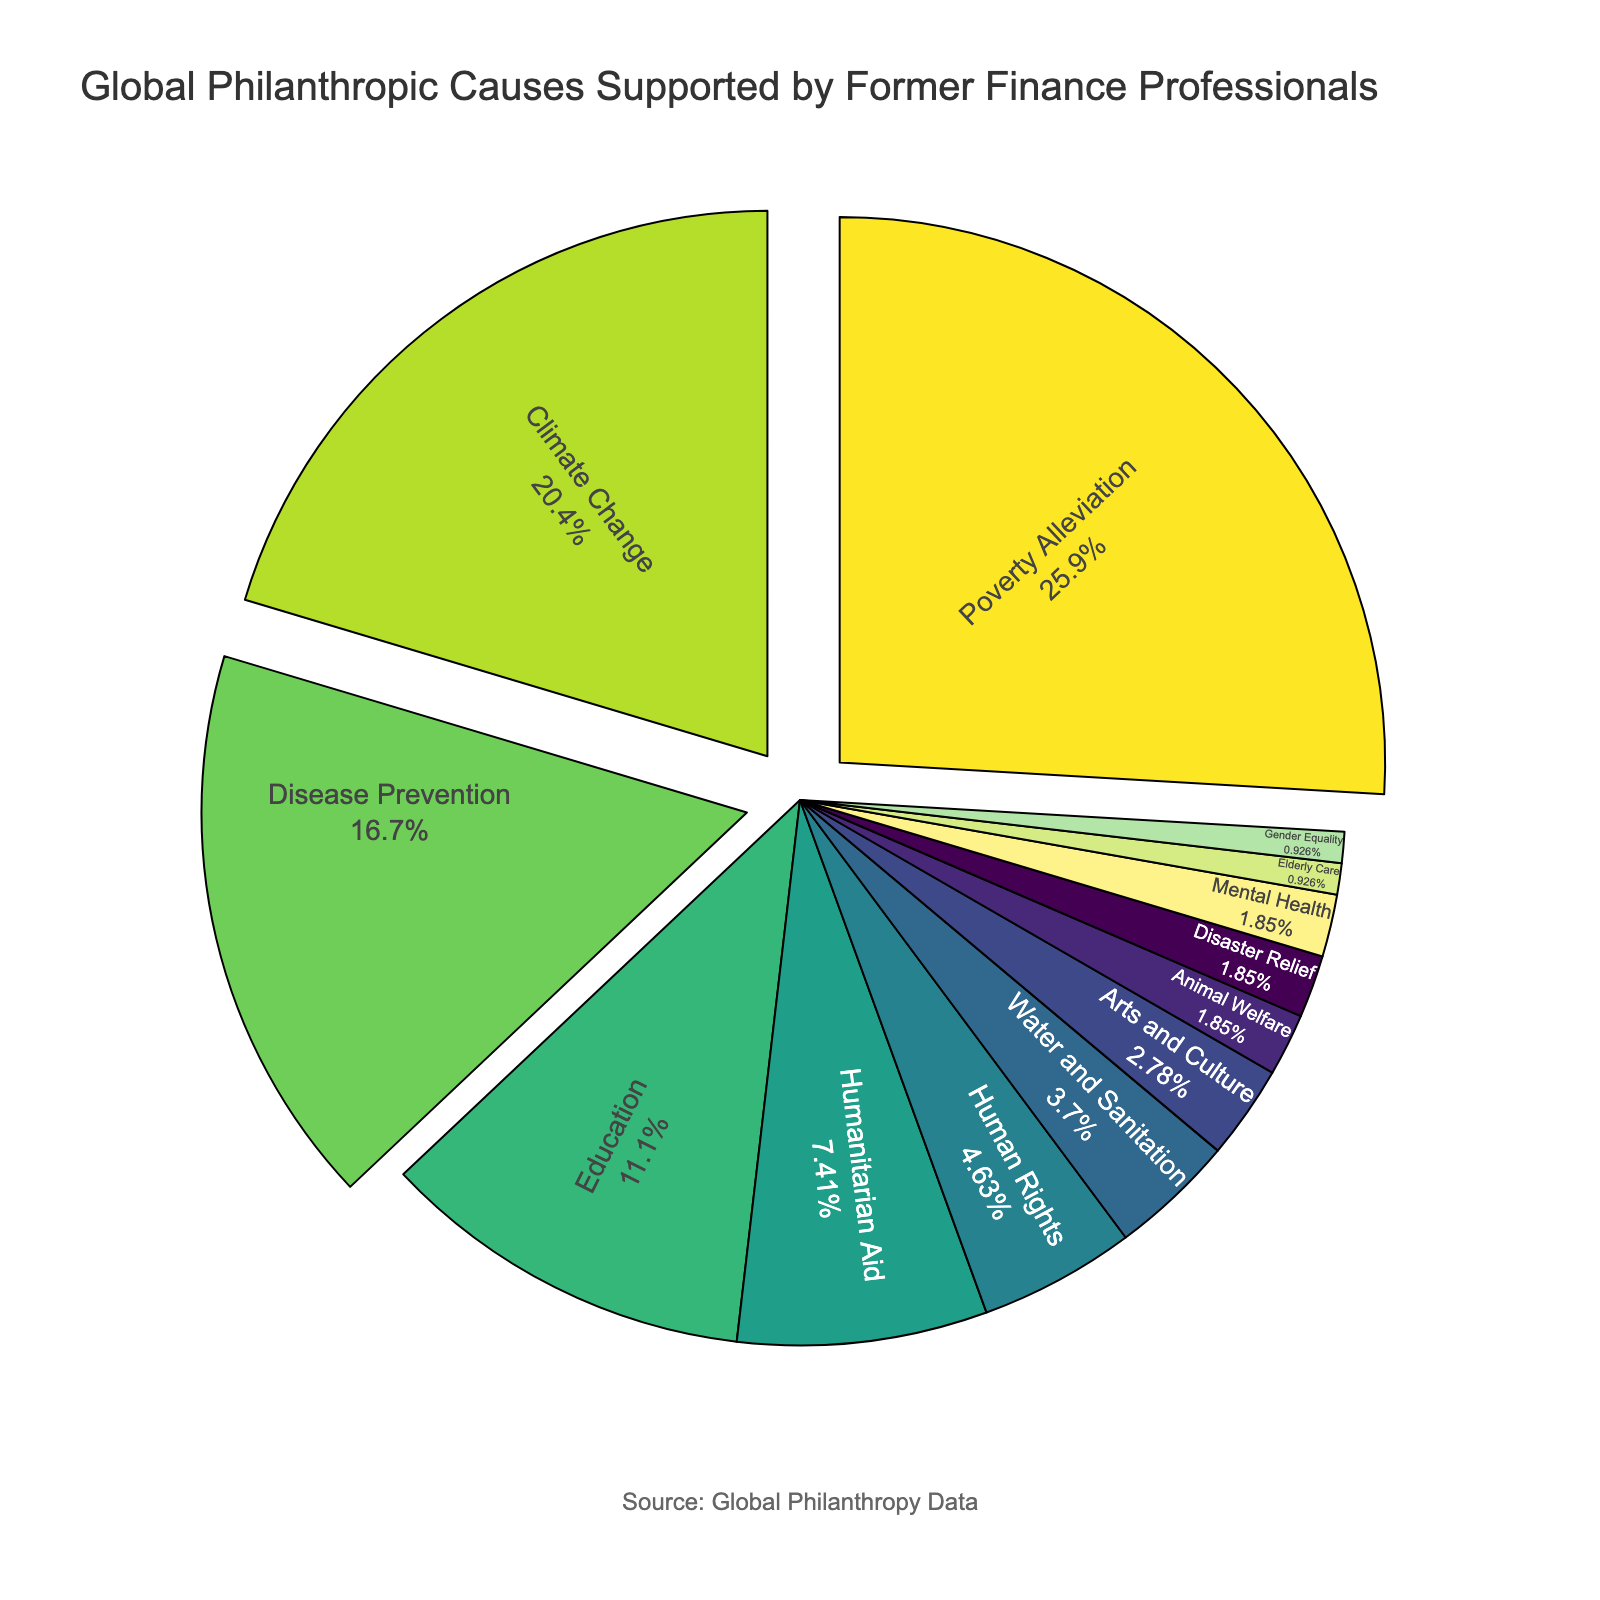what percentage of support goes to the top three causes combined? To find the combined percentage of the top three causes, we add the percentages of Poverty Alleviation, Climate Change, and Disease Prevention. These are 28%, 22%, and 18% respectively. Summing these gives 28 + 22 + 18 = 68.
Answer: 68% Which cause receives more support, Mental Health or Elderly Care? To determine which cause receives more support, we compare the percentages for Mental Health and Elderly Care. Mental Health receives 2% and Elderly Care receives 1%. 2% is greater than 1%.
Answer: Mental Health What is the difference in percentage between Poverty Alleviation and Disease Prevention? Poverty Alleviation receives 28% and Disease Prevention receives 18%. The difference is calculated as 28 - 18 = 10.
Answer: 10% Which causes are represented by the smallest sections of the pie chart? The causes with the smallest sections in the pie chart are those with the lowest percentages. These are Animal Welfare, Disaster Relief, and Gender Equality, each with 2% or 1%.
Answer: Animal Welfare, Disaster Relief, Gender Equality How many causes have a support percentage greater than 20%? By observing the pie chart, we see that Poverty Alleviation (28%) and Climate Change (22%) are the only causes with more than 20%. Thus, the count is 2.
Answer: 2 How does support for Human Rights compare to support for Education? Human Rights receives 5% support, while Education receives 12%. Comparing these, Education has a higher percentage than Human Rights.
Answer: Education is greater What is the average support percentage for the three smallest causes? The three smallest causes are Animal Welfare, Disaster Relief, and Gender Equality, each with percentages of 2%, 2%, and 1%. The average is calculated as (2 + 2 + 1) / 3 = 1.67.
Answer: 1.67% Which has a greater visual prominence due to its positioning, Climate Change or Disease Prevention? The pie chart likely uses color and placement to draw attention. Climate Change, as the section with 22%, might be more prominent with varied color and a larger size compared to Disease Prevention at 18%.
Answer: Climate Change Is there a significant visual difference between the sections for Humanitarian Aid and Human Rights? Humanitarian Aid has 8% and Human Rights has 5%. Visually, a 3% difference may be noticeable but not dramatically so in a pie chart.
Answer: Some difference What percentage of support goes to causes related to health (Disease Prevention, Mental Health)? Summing the support for Disease Prevention (18%) and Mental Health (2%) gives a total of 18 + 2 = 20%.
Answer: 20% 